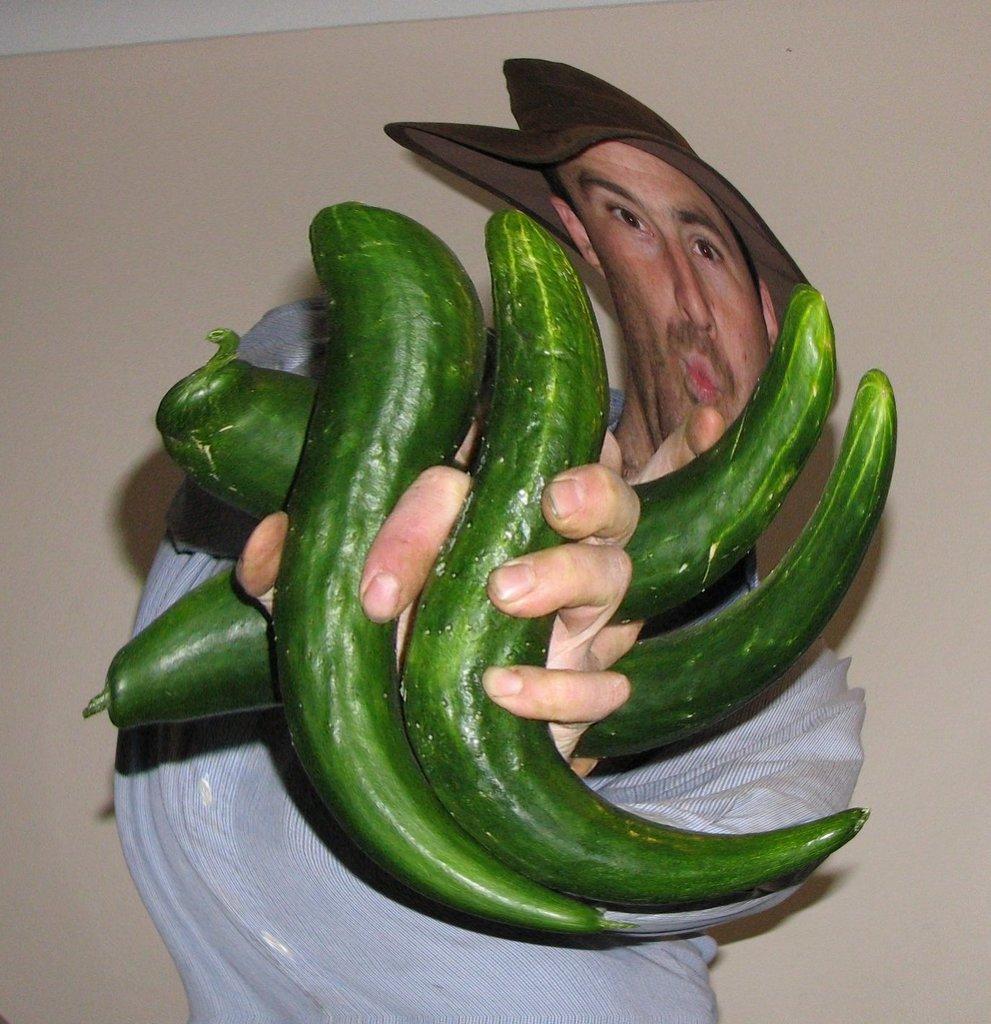In one or two sentences, can you explain what this image depicts? In this image I can see a person holding few green color vegetables. He is wearing white dress. Background is in cream color. 